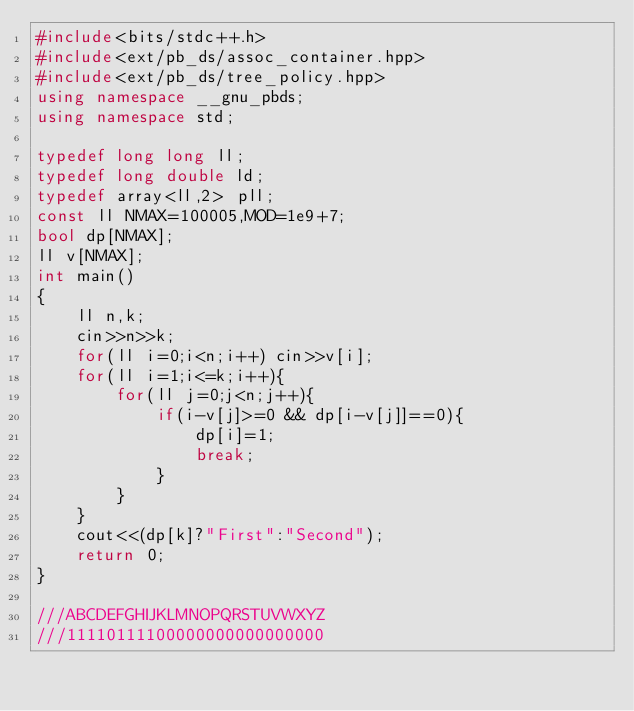<code> <loc_0><loc_0><loc_500><loc_500><_C++_>#include<bits/stdc++.h>
#include<ext/pb_ds/assoc_container.hpp>
#include<ext/pb_ds/tree_policy.hpp>
using namespace __gnu_pbds;
using namespace std;

typedef long long ll;
typedef long double ld;
typedef array<ll,2> pll;
const ll NMAX=100005,MOD=1e9+7;
bool dp[NMAX];
ll v[NMAX];
int main()
{
    ll n,k;
    cin>>n>>k;
    for(ll i=0;i<n;i++) cin>>v[i];
    for(ll i=1;i<=k;i++){
        for(ll j=0;j<n;j++){
            if(i-v[j]>=0 && dp[i-v[j]]==0){
                dp[i]=1;
                break;
            }
        }
    }
    cout<<(dp[k]?"First":"Second");
    return 0;
}

///ABCDEFGHIJKLMNOPQRSTUVWXYZ
///11110111100000000000000000
</code> 